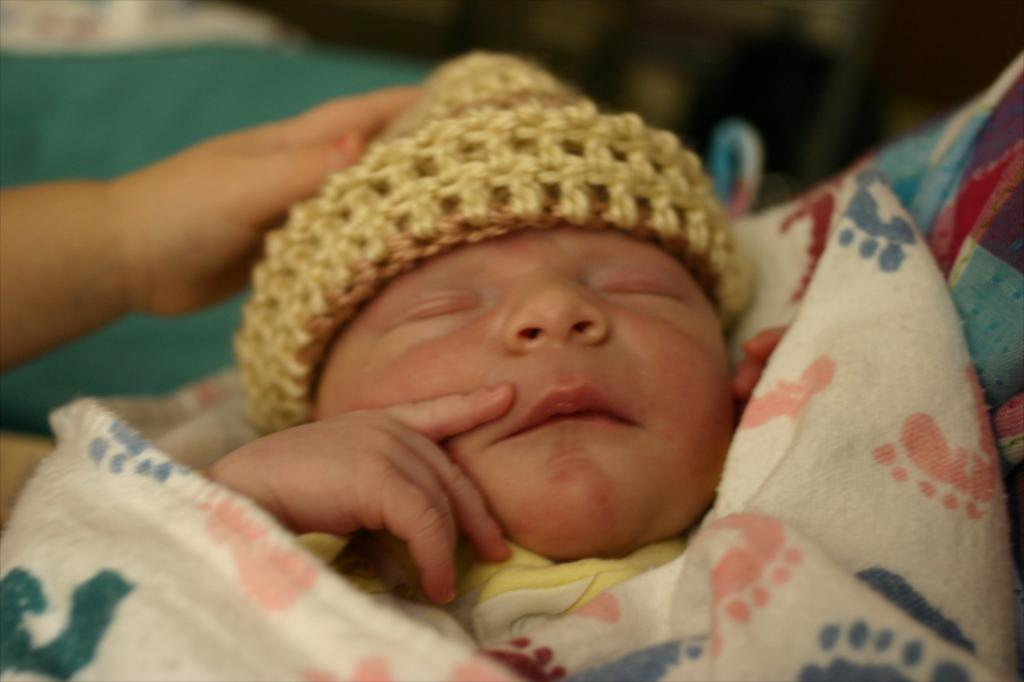What is the main subject of the image? The main subject of the image is a baby. Can you describe the baby's attire? The baby is wearing a cap and is covered with clothes. What type of pail is being used by the porter in the image? There is no porter or pail present in the image; it features a baby wearing a cap and covered with clothes. 